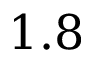Convert formula to latex. <formula><loc_0><loc_0><loc_500><loc_500>1 . 8</formula> 